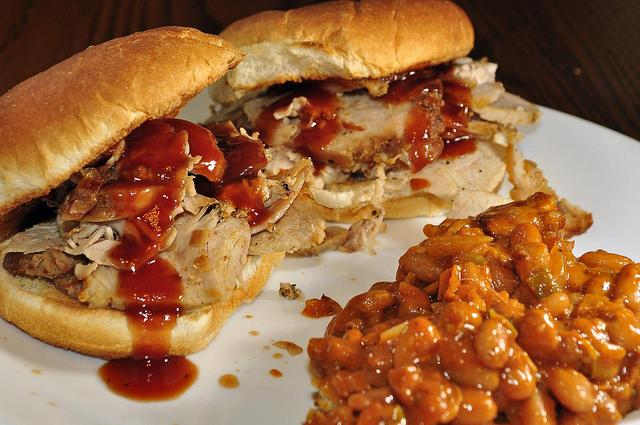What is the original color of the baked beans in the dish? brown 